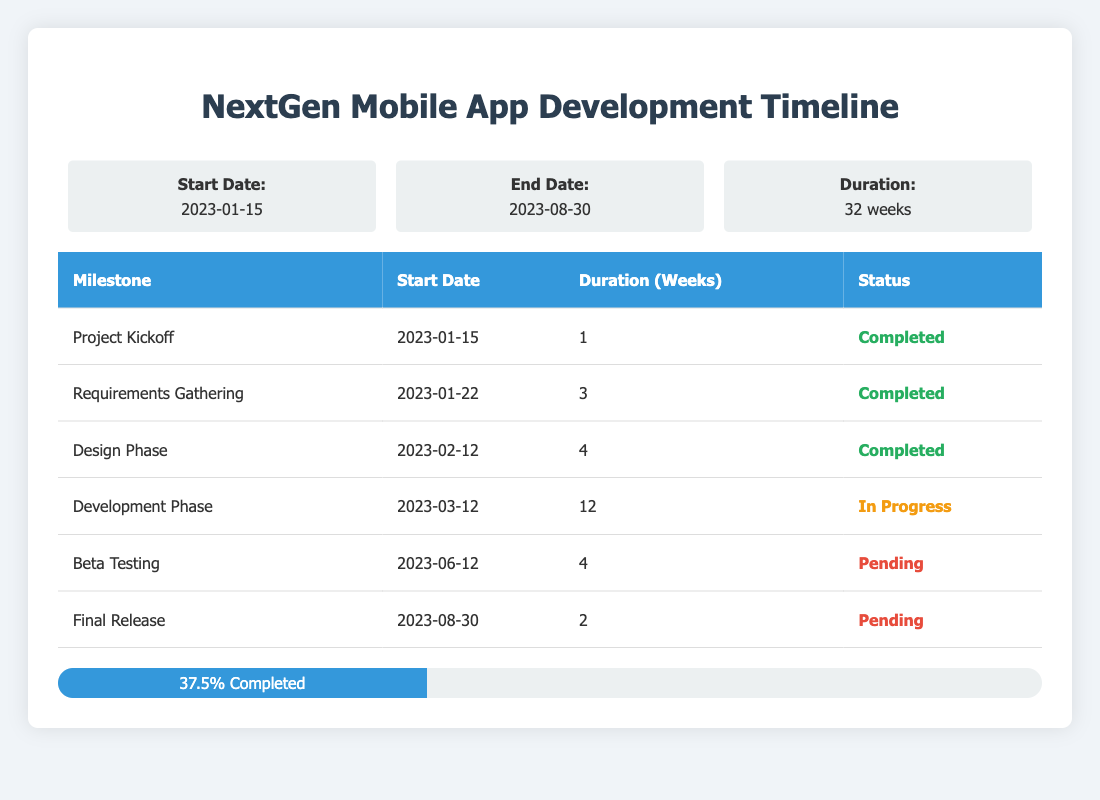What is the status of the Design Phase milestone? In the table, the Design Phase milestone is shown with its status listed as "Completed."
Answer: Completed How many weeks is the Development Phase scheduled for? The Development Phase is indicated in the table with a duration of 12 weeks.
Answer: 12 weeks What is the total number of milestones in this project? By counting the number of rows under the milestones section in the table, we see there are 6 milestones listed.
Answer: 6 How many milestones are currently pending? The table specifies that there are 3 pending milestones listed under the current progress section.
Answer: 3 Is the Beta Testing milestone completed? Referring to the status of the Beta Testing milestone in the table, it indicates "Pending," meaning it is not completed.
Answer: No What percentage of the project milestones have been completed? The table states that 37.5% of the project milestones are completed, which represents the ratio of completed milestones to the total milestones.
Answer: 37.5% What milestones are set to start after the Development Phase? According to the timeline in the table, the Beta Testing milestone follows the Development Phase, starting on 2023-06-12.
Answer: Beta Testing What is the duration difference between Requirements Gathering and the Final Release milestones? The duration of Requirements Gathering is 3 weeks, and the Final Release is 2 weeks. The difference is calculated as 3 - 2 = 1 week.
Answer: 1 week Which milestone has the latest start date, and what is its status? The table indicates that the Final Release milestone has the latest start date of 2023-08-30, and its status is "Pending."
Answer: Final Release, Pending If all pending milestones are completed within 2 weeks, what will be the final completion percentage? Currently, 3 milestones are pending. If completed in 2 weeks, this would result in 6 completed milestones total. The calculation for the completion percentage is (6/6) * 100 = 100%.
Answer: 100% 